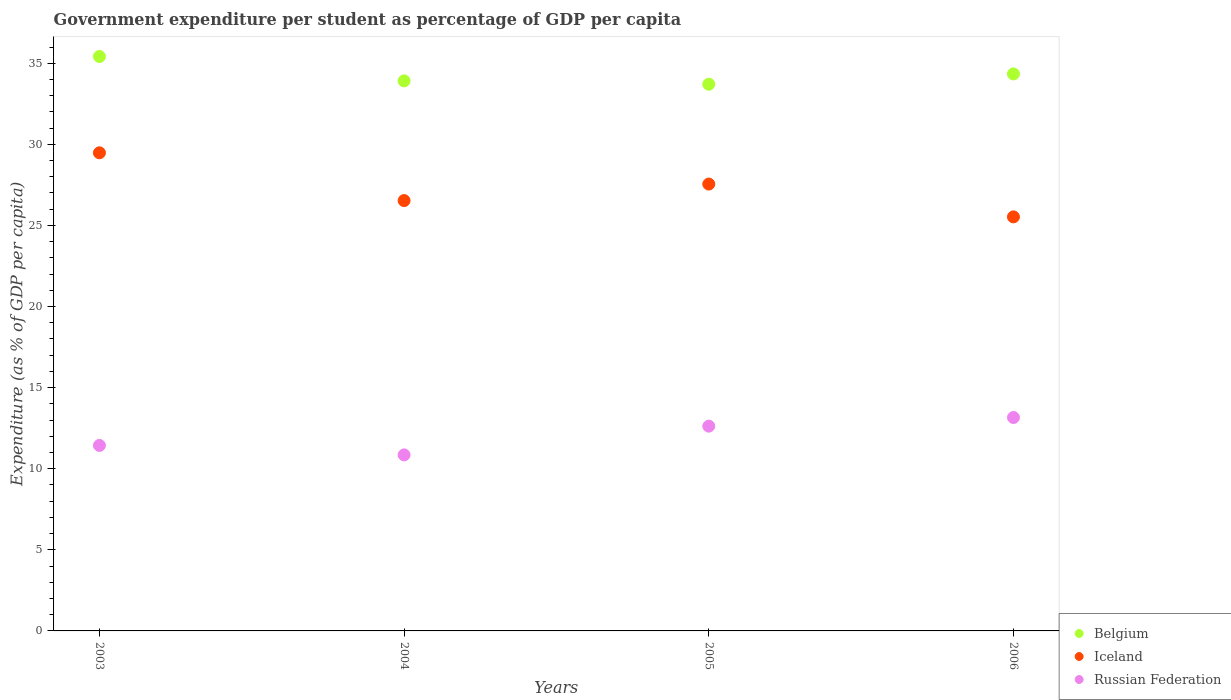How many different coloured dotlines are there?
Your response must be concise. 3. Is the number of dotlines equal to the number of legend labels?
Offer a very short reply. Yes. What is the percentage of expenditure per student in Iceland in 2006?
Keep it short and to the point. 25.53. Across all years, what is the maximum percentage of expenditure per student in Russian Federation?
Keep it short and to the point. 13.16. Across all years, what is the minimum percentage of expenditure per student in Iceland?
Make the answer very short. 25.53. What is the total percentage of expenditure per student in Iceland in the graph?
Give a very brief answer. 109.09. What is the difference between the percentage of expenditure per student in Russian Federation in 2004 and that in 2006?
Offer a very short reply. -2.31. What is the difference between the percentage of expenditure per student in Belgium in 2006 and the percentage of expenditure per student in Russian Federation in 2005?
Ensure brevity in your answer.  21.72. What is the average percentage of expenditure per student in Russian Federation per year?
Provide a short and direct response. 12.02. In the year 2005, what is the difference between the percentage of expenditure per student in Belgium and percentage of expenditure per student in Iceland?
Offer a terse response. 6.16. What is the ratio of the percentage of expenditure per student in Russian Federation in 2004 to that in 2006?
Your answer should be compact. 0.82. Is the percentage of expenditure per student in Belgium in 2004 less than that in 2006?
Offer a terse response. Yes. Is the difference between the percentage of expenditure per student in Belgium in 2004 and 2005 greater than the difference between the percentage of expenditure per student in Iceland in 2004 and 2005?
Offer a terse response. Yes. What is the difference between the highest and the second highest percentage of expenditure per student in Russian Federation?
Your answer should be very brief. 0.53. What is the difference between the highest and the lowest percentage of expenditure per student in Russian Federation?
Give a very brief answer. 2.31. Is it the case that in every year, the sum of the percentage of expenditure per student in Russian Federation and percentage of expenditure per student in Belgium  is greater than the percentage of expenditure per student in Iceland?
Ensure brevity in your answer.  Yes. Does the percentage of expenditure per student in Iceland monotonically increase over the years?
Provide a short and direct response. No. Is the percentage of expenditure per student in Belgium strictly less than the percentage of expenditure per student in Russian Federation over the years?
Your answer should be very brief. No. How many dotlines are there?
Provide a short and direct response. 3. Are the values on the major ticks of Y-axis written in scientific E-notation?
Your answer should be very brief. No. Does the graph contain any zero values?
Your response must be concise. No. How many legend labels are there?
Offer a terse response. 3. How are the legend labels stacked?
Provide a short and direct response. Vertical. What is the title of the graph?
Your response must be concise. Government expenditure per student as percentage of GDP per capita. Does "Marshall Islands" appear as one of the legend labels in the graph?
Offer a very short reply. No. What is the label or title of the Y-axis?
Keep it short and to the point. Expenditure (as % of GDP per capita). What is the Expenditure (as % of GDP per capita) of Belgium in 2003?
Your answer should be very brief. 35.42. What is the Expenditure (as % of GDP per capita) in Iceland in 2003?
Your response must be concise. 29.48. What is the Expenditure (as % of GDP per capita) in Russian Federation in 2003?
Your response must be concise. 11.44. What is the Expenditure (as % of GDP per capita) of Belgium in 2004?
Your answer should be compact. 33.91. What is the Expenditure (as % of GDP per capita) in Iceland in 2004?
Offer a very short reply. 26.53. What is the Expenditure (as % of GDP per capita) of Russian Federation in 2004?
Provide a short and direct response. 10.85. What is the Expenditure (as % of GDP per capita) of Belgium in 2005?
Your answer should be very brief. 33.71. What is the Expenditure (as % of GDP per capita) in Iceland in 2005?
Provide a succinct answer. 27.55. What is the Expenditure (as % of GDP per capita) in Russian Federation in 2005?
Ensure brevity in your answer.  12.63. What is the Expenditure (as % of GDP per capita) of Belgium in 2006?
Ensure brevity in your answer.  34.34. What is the Expenditure (as % of GDP per capita) of Iceland in 2006?
Provide a succinct answer. 25.53. What is the Expenditure (as % of GDP per capita) of Russian Federation in 2006?
Offer a very short reply. 13.16. Across all years, what is the maximum Expenditure (as % of GDP per capita) in Belgium?
Your response must be concise. 35.42. Across all years, what is the maximum Expenditure (as % of GDP per capita) in Iceland?
Provide a succinct answer. 29.48. Across all years, what is the maximum Expenditure (as % of GDP per capita) in Russian Federation?
Give a very brief answer. 13.16. Across all years, what is the minimum Expenditure (as % of GDP per capita) in Belgium?
Ensure brevity in your answer.  33.71. Across all years, what is the minimum Expenditure (as % of GDP per capita) in Iceland?
Ensure brevity in your answer.  25.53. Across all years, what is the minimum Expenditure (as % of GDP per capita) in Russian Federation?
Offer a very short reply. 10.85. What is the total Expenditure (as % of GDP per capita) in Belgium in the graph?
Make the answer very short. 137.38. What is the total Expenditure (as % of GDP per capita) in Iceland in the graph?
Your answer should be compact. 109.09. What is the total Expenditure (as % of GDP per capita) in Russian Federation in the graph?
Offer a terse response. 48.07. What is the difference between the Expenditure (as % of GDP per capita) of Belgium in 2003 and that in 2004?
Offer a very short reply. 1.5. What is the difference between the Expenditure (as % of GDP per capita) in Iceland in 2003 and that in 2004?
Provide a short and direct response. 2.95. What is the difference between the Expenditure (as % of GDP per capita) of Russian Federation in 2003 and that in 2004?
Offer a very short reply. 0.58. What is the difference between the Expenditure (as % of GDP per capita) in Belgium in 2003 and that in 2005?
Offer a terse response. 1.71. What is the difference between the Expenditure (as % of GDP per capita) in Iceland in 2003 and that in 2005?
Give a very brief answer. 1.93. What is the difference between the Expenditure (as % of GDP per capita) in Russian Federation in 2003 and that in 2005?
Offer a terse response. -1.19. What is the difference between the Expenditure (as % of GDP per capita) of Belgium in 2003 and that in 2006?
Ensure brevity in your answer.  1.07. What is the difference between the Expenditure (as % of GDP per capita) of Iceland in 2003 and that in 2006?
Your answer should be very brief. 3.95. What is the difference between the Expenditure (as % of GDP per capita) of Russian Federation in 2003 and that in 2006?
Keep it short and to the point. -1.72. What is the difference between the Expenditure (as % of GDP per capita) of Belgium in 2004 and that in 2005?
Your answer should be very brief. 0.21. What is the difference between the Expenditure (as % of GDP per capita) in Iceland in 2004 and that in 2005?
Ensure brevity in your answer.  -1.02. What is the difference between the Expenditure (as % of GDP per capita) in Russian Federation in 2004 and that in 2005?
Give a very brief answer. -1.77. What is the difference between the Expenditure (as % of GDP per capita) in Belgium in 2004 and that in 2006?
Offer a very short reply. -0.43. What is the difference between the Expenditure (as % of GDP per capita) of Russian Federation in 2004 and that in 2006?
Offer a very short reply. -2.31. What is the difference between the Expenditure (as % of GDP per capita) of Belgium in 2005 and that in 2006?
Offer a very short reply. -0.64. What is the difference between the Expenditure (as % of GDP per capita) of Iceland in 2005 and that in 2006?
Give a very brief answer. 2.02. What is the difference between the Expenditure (as % of GDP per capita) in Russian Federation in 2005 and that in 2006?
Your response must be concise. -0.53. What is the difference between the Expenditure (as % of GDP per capita) of Belgium in 2003 and the Expenditure (as % of GDP per capita) of Iceland in 2004?
Your response must be concise. 8.88. What is the difference between the Expenditure (as % of GDP per capita) of Belgium in 2003 and the Expenditure (as % of GDP per capita) of Russian Federation in 2004?
Your response must be concise. 24.56. What is the difference between the Expenditure (as % of GDP per capita) in Iceland in 2003 and the Expenditure (as % of GDP per capita) in Russian Federation in 2004?
Ensure brevity in your answer.  18.63. What is the difference between the Expenditure (as % of GDP per capita) of Belgium in 2003 and the Expenditure (as % of GDP per capita) of Iceland in 2005?
Ensure brevity in your answer.  7.86. What is the difference between the Expenditure (as % of GDP per capita) in Belgium in 2003 and the Expenditure (as % of GDP per capita) in Russian Federation in 2005?
Your answer should be compact. 22.79. What is the difference between the Expenditure (as % of GDP per capita) in Iceland in 2003 and the Expenditure (as % of GDP per capita) in Russian Federation in 2005?
Provide a short and direct response. 16.85. What is the difference between the Expenditure (as % of GDP per capita) in Belgium in 2003 and the Expenditure (as % of GDP per capita) in Iceland in 2006?
Ensure brevity in your answer.  9.89. What is the difference between the Expenditure (as % of GDP per capita) in Belgium in 2003 and the Expenditure (as % of GDP per capita) in Russian Federation in 2006?
Provide a succinct answer. 22.26. What is the difference between the Expenditure (as % of GDP per capita) in Iceland in 2003 and the Expenditure (as % of GDP per capita) in Russian Federation in 2006?
Offer a terse response. 16.32. What is the difference between the Expenditure (as % of GDP per capita) in Belgium in 2004 and the Expenditure (as % of GDP per capita) in Iceland in 2005?
Provide a short and direct response. 6.36. What is the difference between the Expenditure (as % of GDP per capita) of Belgium in 2004 and the Expenditure (as % of GDP per capita) of Russian Federation in 2005?
Keep it short and to the point. 21.29. What is the difference between the Expenditure (as % of GDP per capita) in Iceland in 2004 and the Expenditure (as % of GDP per capita) in Russian Federation in 2005?
Provide a succinct answer. 13.91. What is the difference between the Expenditure (as % of GDP per capita) of Belgium in 2004 and the Expenditure (as % of GDP per capita) of Iceland in 2006?
Keep it short and to the point. 8.39. What is the difference between the Expenditure (as % of GDP per capita) in Belgium in 2004 and the Expenditure (as % of GDP per capita) in Russian Federation in 2006?
Give a very brief answer. 20.75. What is the difference between the Expenditure (as % of GDP per capita) in Iceland in 2004 and the Expenditure (as % of GDP per capita) in Russian Federation in 2006?
Your answer should be compact. 13.37. What is the difference between the Expenditure (as % of GDP per capita) in Belgium in 2005 and the Expenditure (as % of GDP per capita) in Iceland in 2006?
Your answer should be compact. 8.18. What is the difference between the Expenditure (as % of GDP per capita) in Belgium in 2005 and the Expenditure (as % of GDP per capita) in Russian Federation in 2006?
Provide a succinct answer. 20.55. What is the difference between the Expenditure (as % of GDP per capita) of Iceland in 2005 and the Expenditure (as % of GDP per capita) of Russian Federation in 2006?
Provide a succinct answer. 14.39. What is the average Expenditure (as % of GDP per capita) of Belgium per year?
Ensure brevity in your answer.  34.34. What is the average Expenditure (as % of GDP per capita) of Iceland per year?
Your response must be concise. 27.27. What is the average Expenditure (as % of GDP per capita) of Russian Federation per year?
Your response must be concise. 12.02. In the year 2003, what is the difference between the Expenditure (as % of GDP per capita) of Belgium and Expenditure (as % of GDP per capita) of Iceland?
Provide a succinct answer. 5.94. In the year 2003, what is the difference between the Expenditure (as % of GDP per capita) of Belgium and Expenditure (as % of GDP per capita) of Russian Federation?
Keep it short and to the point. 23.98. In the year 2003, what is the difference between the Expenditure (as % of GDP per capita) in Iceland and Expenditure (as % of GDP per capita) in Russian Federation?
Give a very brief answer. 18.04. In the year 2004, what is the difference between the Expenditure (as % of GDP per capita) in Belgium and Expenditure (as % of GDP per capita) in Iceland?
Make the answer very short. 7.38. In the year 2004, what is the difference between the Expenditure (as % of GDP per capita) of Belgium and Expenditure (as % of GDP per capita) of Russian Federation?
Ensure brevity in your answer.  23.06. In the year 2004, what is the difference between the Expenditure (as % of GDP per capita) of Iceland and Expenditure (as % of GDP per capita) of Russian Federation?
Your response must be concise. 15.68. In the year 2005, what is the difference between the Expenditure (as % of GDP per capita) of Belgium and Expenditure (as % of GDP per capita) of Iceland?
Offer a terse response. 6.16. In the year 2005, what is the difference between the Expenditure (as % of GDP per capita) in Belgium and Expenditure (as % of GDP per capita) in Russian Federation?
Make the answer very short. 21.08. In the year 2005, what is the difference between the Expenditure (as % of GDP per capita) of Iceland and Expenditure (as % of GDP per capita) of Russian Federation?
Offer a terse response. 14.93. In the year 2006, what is the difference between the Expenditure (as % of GDP per capita) of Belgium and Expenditure (as % of GDP per capita) of Iceland?
Make the answer very short. 8.81. In the year 2006, what is the difference between the Expenditure (as % of GDP per capita) of Belgium and Expenditure (as % of GDP per capita) of Russian Federation?
Make the answer very short. 21.18. In the year 2006, what is the difference between the Expenditure (as % of GDP per capita) in Iceland and Expenditure (as % of GDP per capita) in Russian Federation?
Your response must be concise. 12.37. What is the ratio of the Expenditure (as % of GDP per capita) of Belgium in 2003 to that in 2004?
Give a very brief answer. 1.04. What is the ratio of the Expenditure (as % of GDP per capita) of Iceland in 2003 to that in 2004?
Provide a short and direct response. 1.11. What is the ratio of the Expenditure (as % of GDP per capita) of Russian Federation in 2003 to that in 2004?
Your response must be concise. 1.05. What is the ratio of the Expenditure (as % of GDP per capita) of Belgium in 2003 to that in 2005?
Give a very brief answer. 1.05. What is the ratio of the Expenditure (as % of GDP per capita) of Iceland in 2003 to that in 2005?
Give a very brief answer. 1.07. What is the ratio of the Expenditure (as % of GDP per capita) of Russian Federation in 2003 to that in 2005?
Your answer should be compact. 0.91. What is the ratio of the Expenditure (as % of GDP per capita) in Belgium in 2003 to that in 2006?
Give a very brief answer. 1.03. What is the ratio of the Expenditure (as % of GDP per capita) of Iceland in 2003 to that in 2006?
Provide a succinct answer. 1.15. What is the ratio of the Expenditure (as % of GDP per capita) of Russian Federation in 2003 to that in 2006?
Keep it short and to the point. 0.87. What is the ratio of the Expenditure (as % of GDP per capita) in Iceland in 2004 to that in 2005?
Your answer should be very brief. 0.96. What is the ratio of the Expenditure (as % of GDP per capita) of Russian Federation in 2004 to that in 2005?
Your response must be concise. 0.86. What is the ratio of the Expenditure (as % of GDP per capita) in Belgium in 2004 to that in 2006?
Give a very brief answer. 0.99. What is the ratio of the Expenditure (as % of GDP per capita) of Iceland in 2004 to that in 2006?
Provide a succinct answer. 1.04. What is the ratio of the Expenditure (as % of GDP per capita) of Russian Federation in 2004 to that in 2006?
Provide a succinct answer. 0.82. What is the ratio of the Expenditure (as % of GDP per capita) of Belgium in 2005 to that in 2006?
Provide a succinct answer. 0.98. What is the ratio of the Expenditure (as % of GDP per capita) in Iceland in 2005 to that in 2006?
Offer a very short reply. 1.08. What is the ratio of the Expenditure (as % of GDP per capita) in Russian Federation in 2005 to that in 2006?
Your answer should be very brief. 0.96. What is the difference between the highest and the second highest Expenditure (as % of GDP per capita) of Belgium?
Give a very brief answer. 1.07. What is the difference between the highest and the second highest Expenditure (as % of GDP per capita) of Iceland?
Provide a short and direct response. 1.93. What is the difference between the highest and the second highest Expenditure (as % of GDP per capita) in Russian Federation?
Offer a terse response. 0.53. What is the difference between the highest and the lowest Expenditure (as % of GDP per capita) of Belgium?
Your answer should be compact. 1.71. What is the difference between the highest and the lowest Expenditure (as % of GDP per capita) in Iceland?
Keep it short and to the point. 3.95. What is the difference between the highest and the lowest Expenditure (as % of GDP per capita) in Russian Federation?
Make the answer very short. 2.31. 